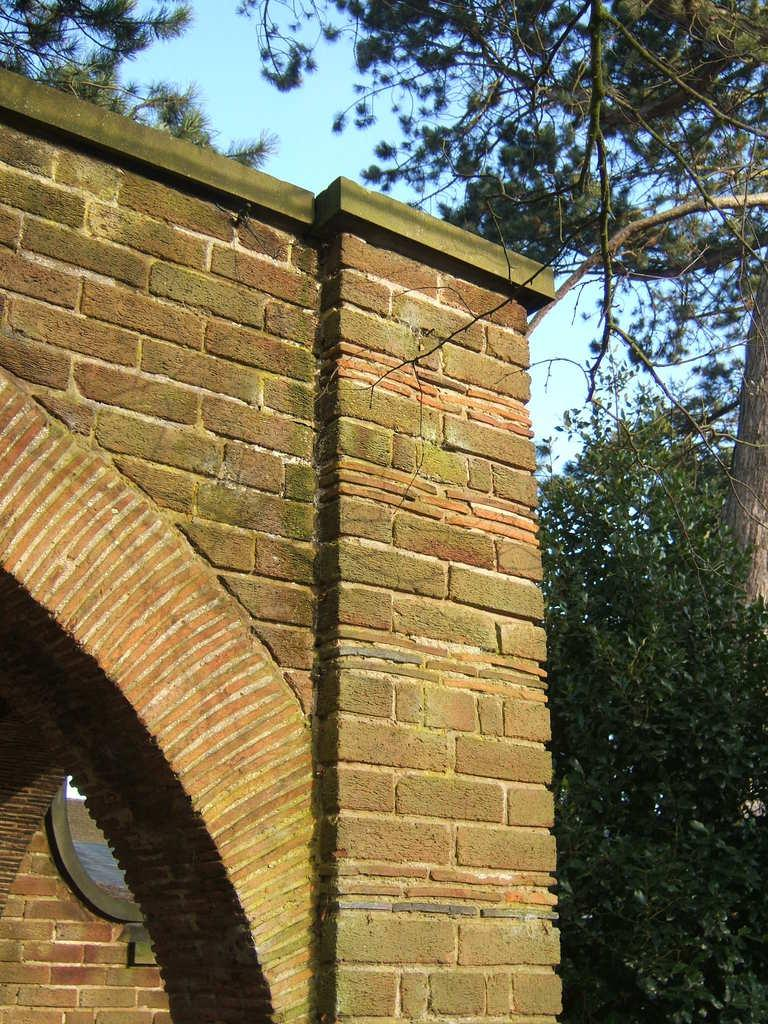What type of structure is featured in the image? There is a building with an arch in the image. What can be seen on either side of the building? There are trees on the sides of the building. What is visible in the background of the image? The sky is visible in the background of the image. What type of riddle is being solved by the trees in the image? There is no riddle being solved by the trees in the image; they are simply trees on the sides of the building. 